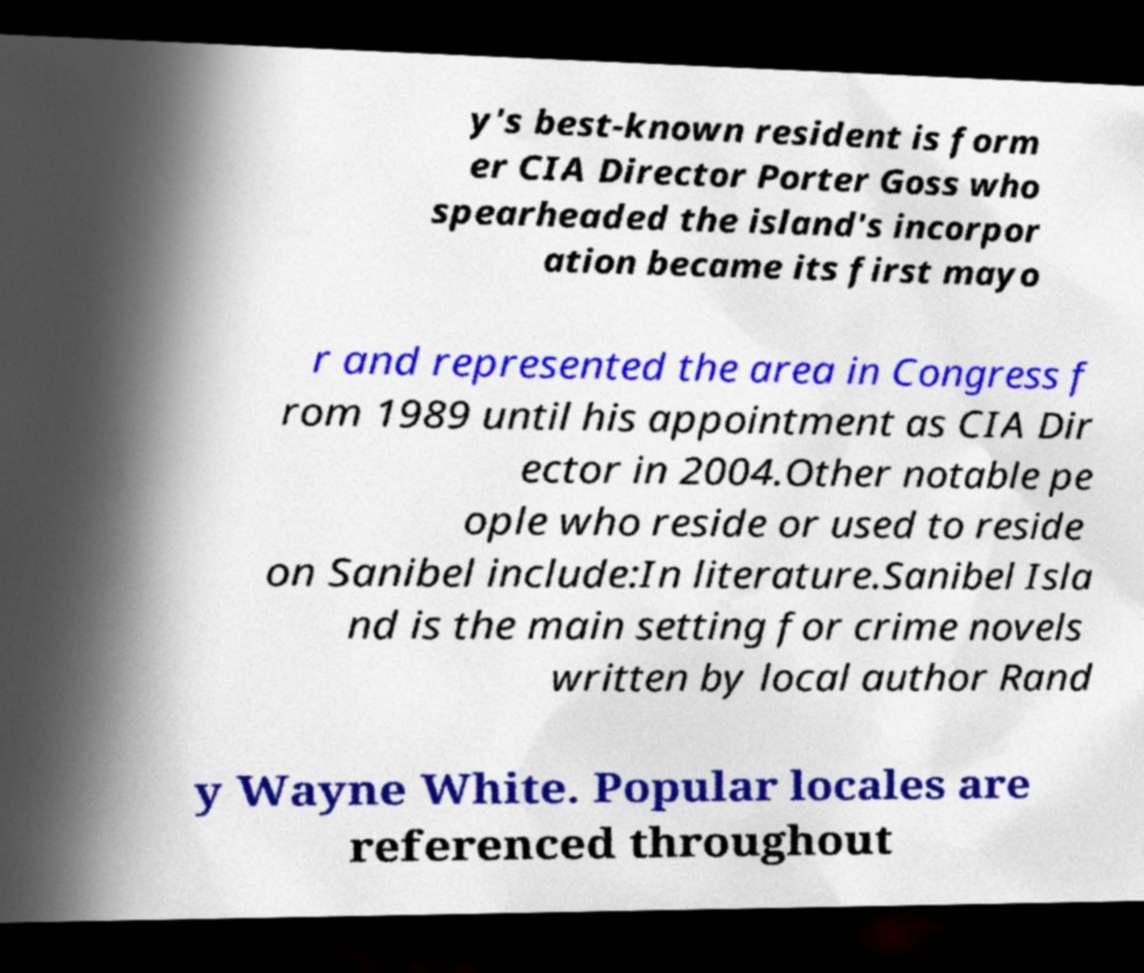For documentation purposes, I need the text within this image transcribed. Could you provide that? y's best-known resident is form er CIA Director Porter Goss who spearheaded the island's incorpor ation became its first mayo r and represented the area in Congress f rom 1989 until his appointment as CIA Dir ector in 2004.Other notable pe ople who reside or used to reside on Sanibel include:In literature.Sanibel Isla nd is the main setting for crime novels written by local author Rand y Wayne White. Popular locales are referenced throughout 